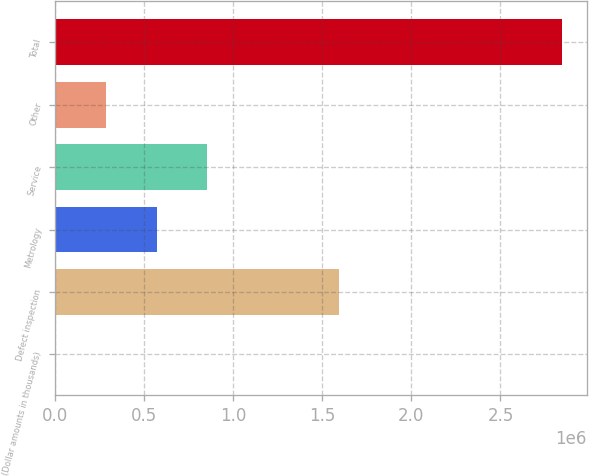Convert chart to OTSL. <chart><loc_0><loc_0><loc_500><loc_500><bar_chart><fcel>(Dollar amounts in thousands)<fcel>Defect inspection<fcel>Metrology<fcel>Service<fcel>Other<fcel>Total<nl><fcel>2013<fcel>1.59413e+06<fcel>570167<fcel>854243<fcel>286090<fcel>2.84278e+06<nl></chart> 